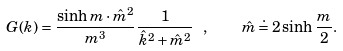Convert formula to latex. <formula><loc_0><loc_0><loc_500><loc_500>G ( k ) = \frac { \sinh m \cdot \hat { m } ^ { 2 } } { m ^ { 3 } } \frac { 1 } { \hat { k } ^ { 2 } + \hat { m } ^ { 2 } } \ , \quad \hat { m } \doteq 2 \sinh \frac { m } { 2 } .</formula> 